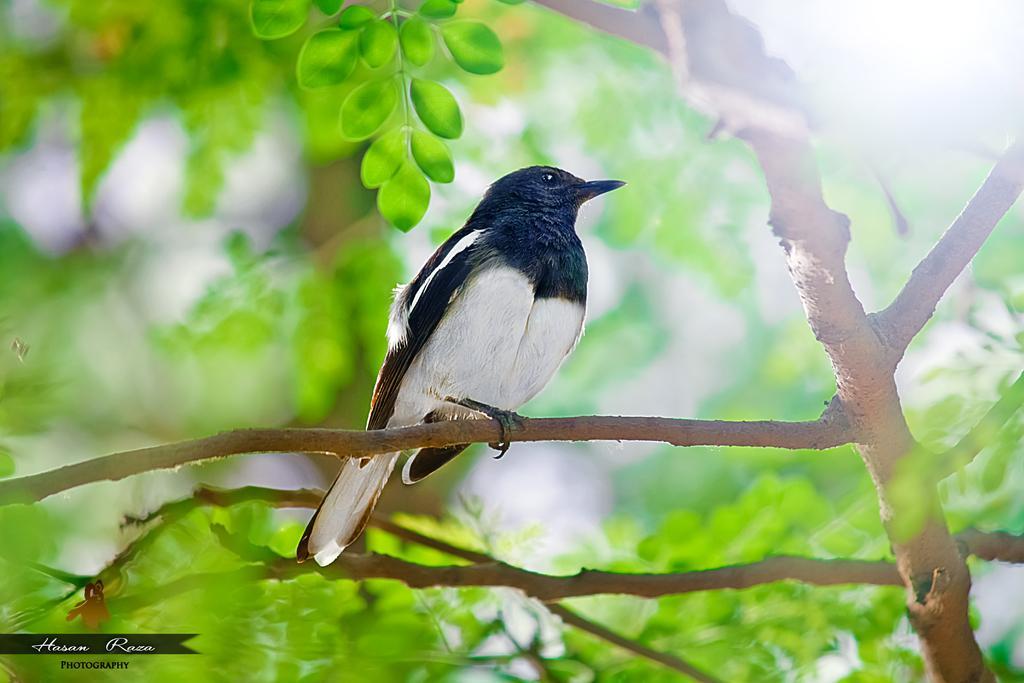Could you give a brief overview of what you see in this image? In this picture we can see a bird on the tree. 